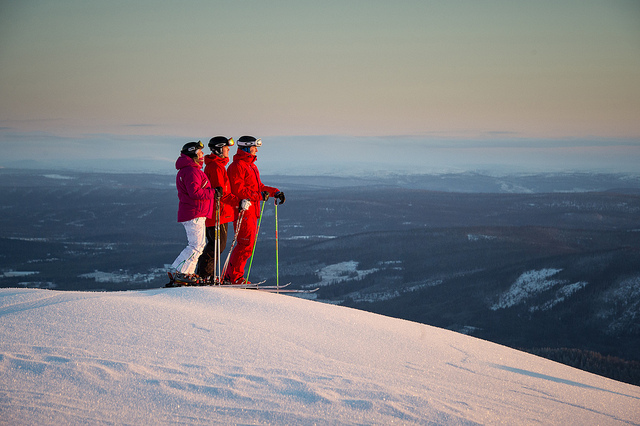What time of day does it seem to be in the image? The long shadows and warm hues on the snow suggest that this photo was taken during the golden hours, which typically occur shortly after sunrise or before sunset. This is a time when the light has a soft, diffused quality. 